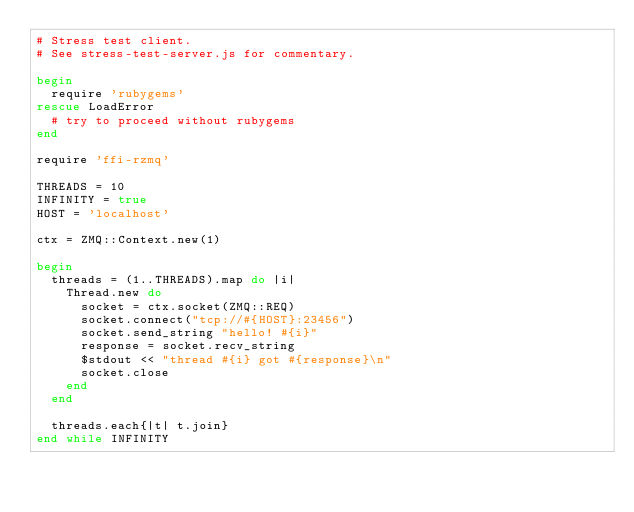Convert code to text. <code><loc_0><loc_0><loc_500><loc_500><_Ruby_># Stress test client.
# See stress-test-server.js for commentary.

begin
  require 'rubygems'
rescue LoadError
  # try to proceed without rubygems
end

require 'ffi-rzmq'

THREADS = 10
INFINITY = true
HOST = 'localhost'

ctx = ZMQ::Context.new(1)

begin
  threads = (1..THREADS).map do |i|
    Thread.new do
      socket = ctx.socket(ZMQ::REQ)
      socket.connect("tcp://#{HOST}:23456")
      socket.send_string "hello! #{i}"
      response = socket.recv_string
      $stdout << "thread #{i} got #{response}\n"
      socket.close
    end
  end

  threads.each{|t| t.join}
end while INFINITY
</code> 